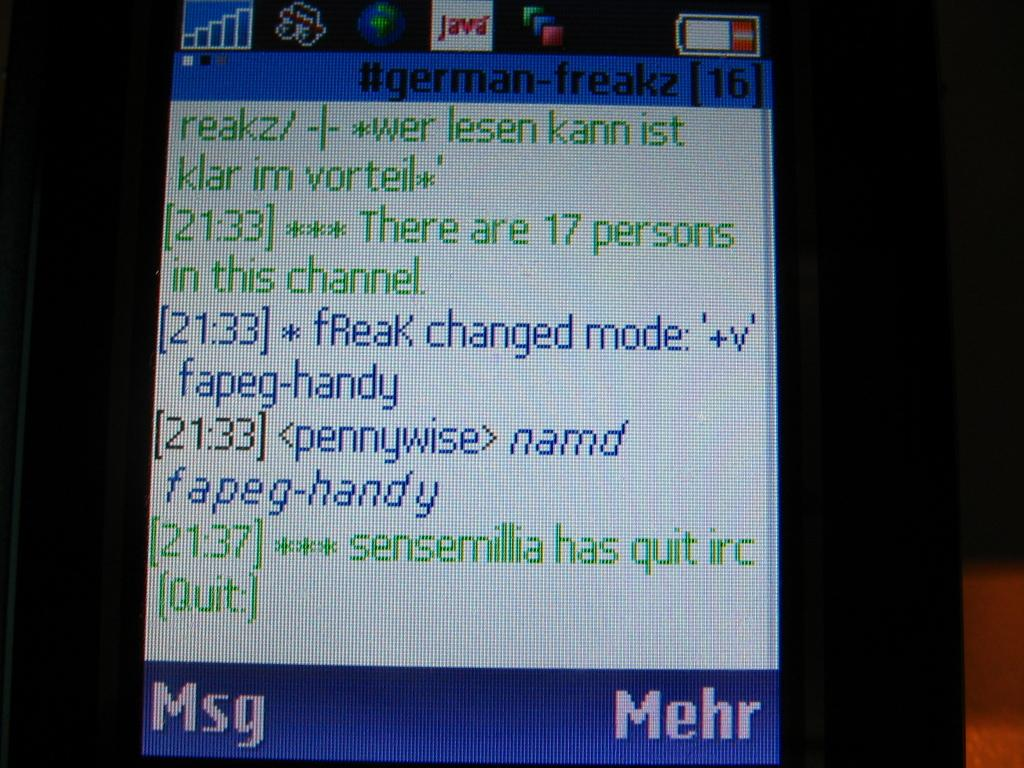<image>
Describe the image concisely. a text message conversation at 21:33 on a small screen in blue and green text writing 